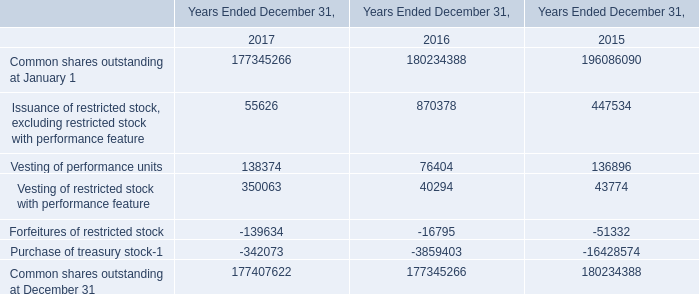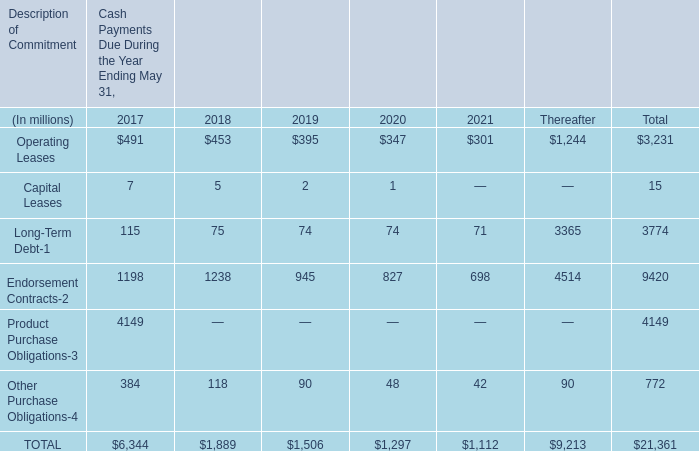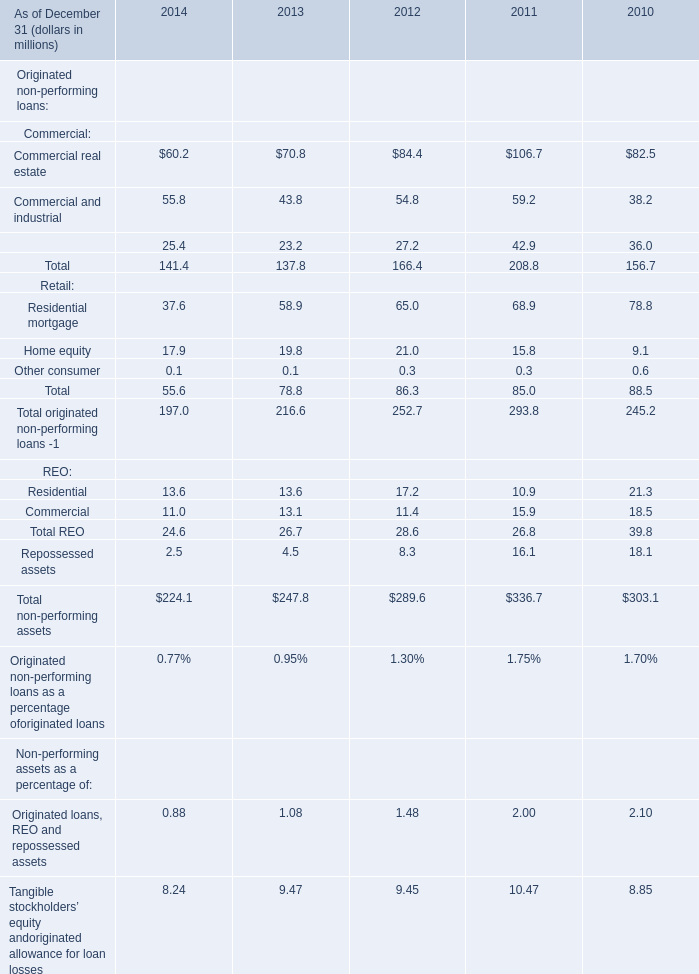as of may 31 , 2016 what percentage of cash and cash equivalents was held in foreign subsidiaries? 
Computations: (4.6 / 5.5)
Answer: 0.83636. 